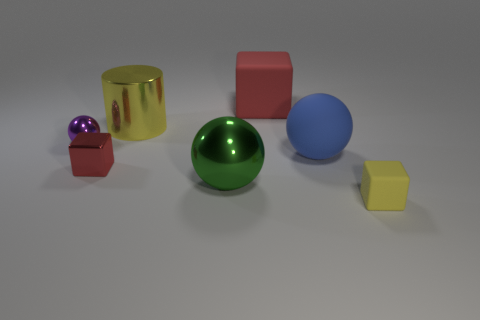Subtract all small yellow rubber blocks. How many blocks are left? 2 Subtract all yellow blocks. How many blocks are left? 2 Subtract 1 blue balls. How many objects are left? 6 Subtract all cylinders. How many objects are left? 6 Subtract 2 cubes. How many cubes are left? 1 Subtract all green cubes. Subtract all brown spheres. How many cubes are left? 3 Subtract all green spheres. How many red cubes are left? 2 Subtract all blue spheres. Subtract all tiny purple things. How many objects are left? 5 Add 1 tiny purple shiny spheres. How many tiny purple shiny spheres are left? 2 Add 1 big green metallic spheres. How many big green metallic spheres exist? 2 